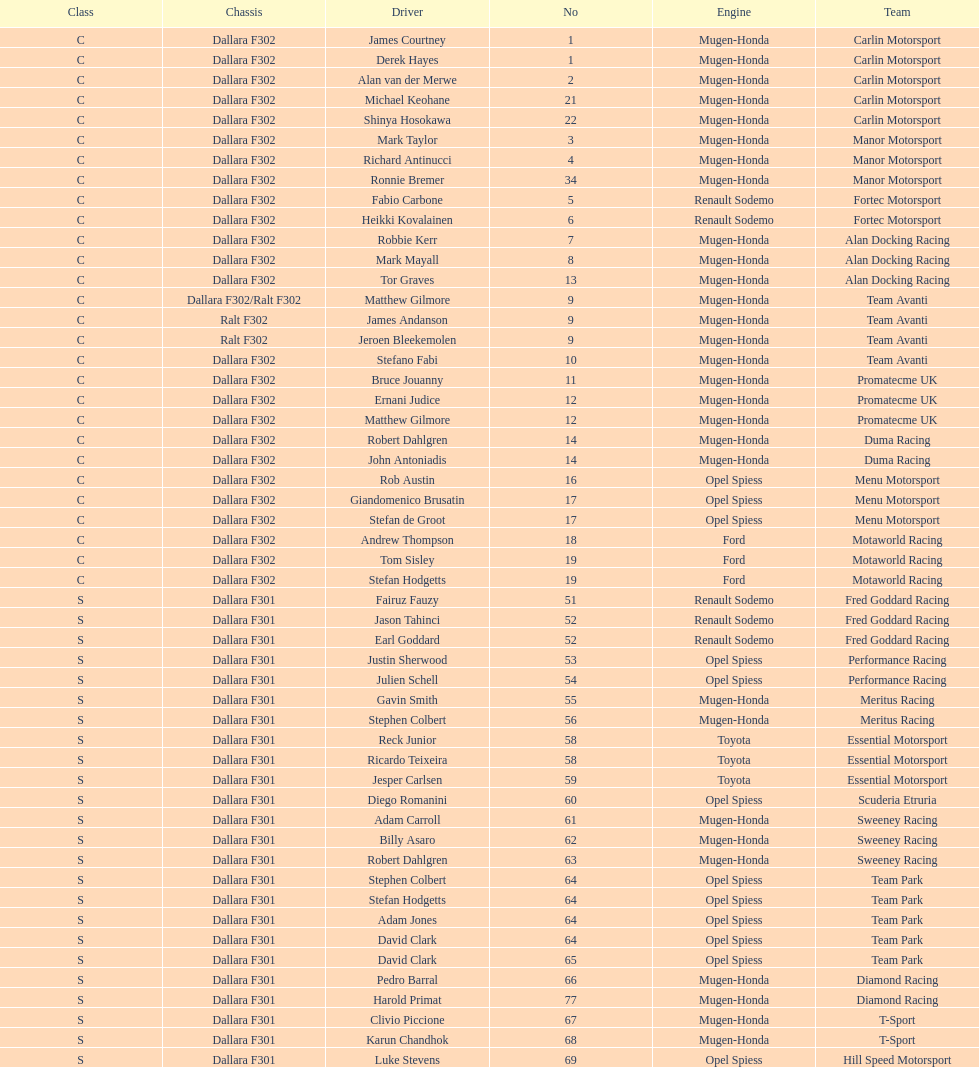Who had more drivers, team avanti or motaworld racing? Team Avanti. 